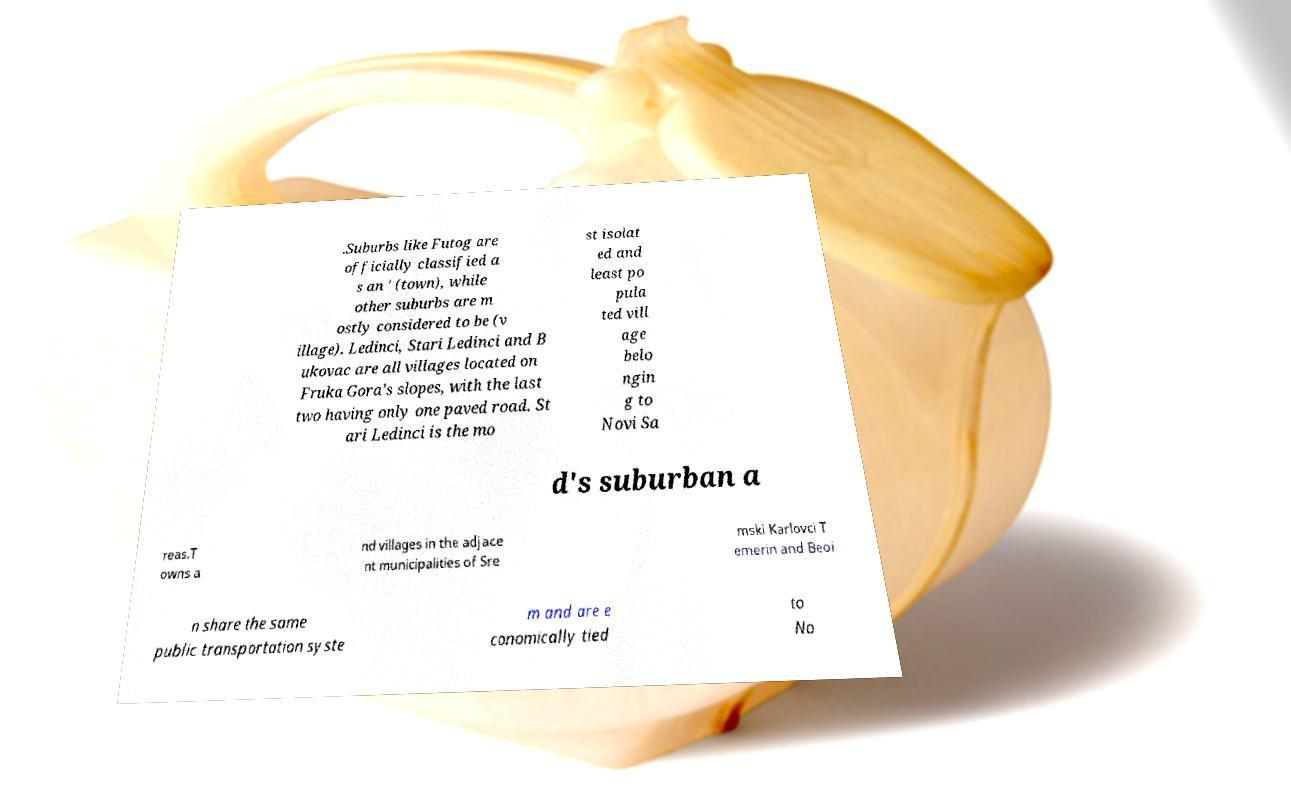I need the written content from this picture converted into text. Can you do that? .Suburbs like Futog are officially classified a s an ' (town), while other suburbs are m ostly considered to be (v illage). Ledinci, Stari Ledinci and B ukovac are all villages located on Fruka Gora’s slopes, with the last two having only one paved road. St ari Ledinci is the mo st isolat ed and least po pula ted vill age belo ngin g to Novi Sa d's suburban a reas.T owns a nd villages in the adjace nt municipalities of Sre mski Karlovci T emerin and Beoi n share the same public transportation syste m and are e conomically tied to No 